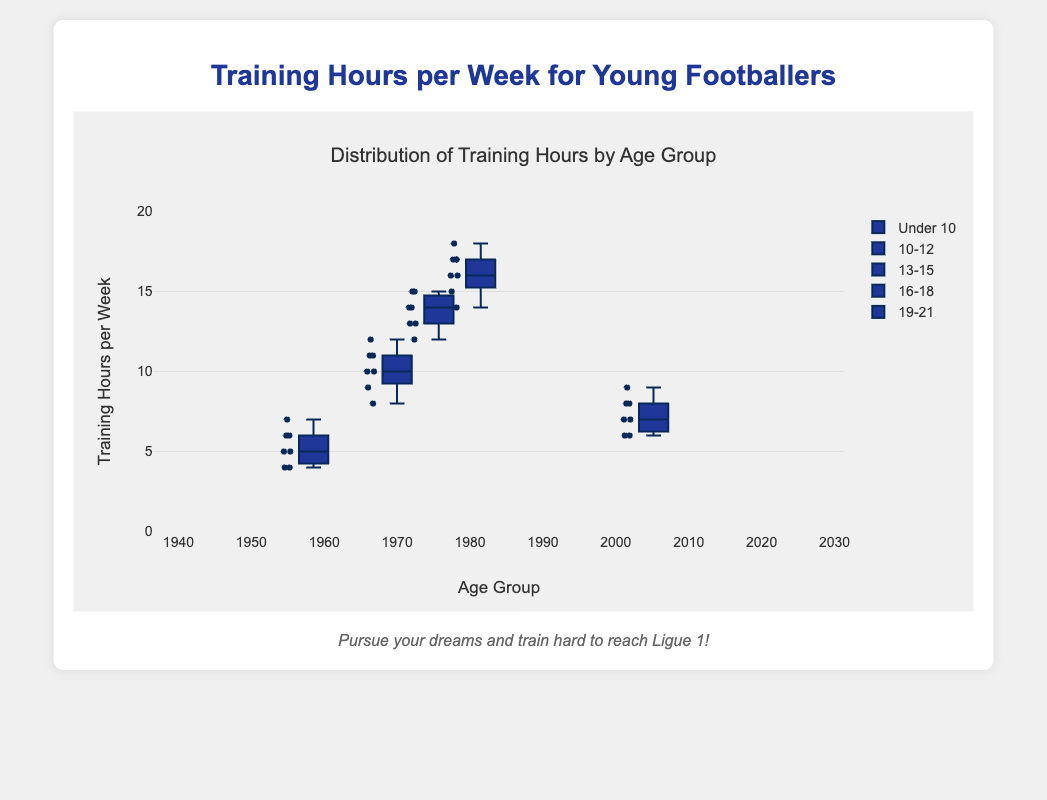What is the title of the box plot? The title of the box plot is usually displayed at the top of the figure. In this case, it reads "Distribution of Training Hours by Age Group".
Answer: Distribution of Training Hours by Age Group What is the median training hours per week for the 10-12 age group? To find the median training hours for the 10-12 age group, look at the middle line within the box for that age group. This line represents the median.
Answer: 7 hours Which age group has the highest median training hours per week? By examining the middle line (median) within each box, we identify the group with the highest median training hours. The 19-21 age group has the highest median value.
Answer: 19-21 age group How do the training hours for the Under 10 age group compare to the 13-15 age group in terms of range? To compare the range, look at the spread of the whiskers (vertical lines) for each group. The range for the Under 10 age group is from 4 hours to 7 hours, while the range for the 13-15 age group is from 8 hours to 12 hours. Thus, the 13-15 age group has a wider range of training hours.
Answer: 13-15 age group has a wider range What is the interquartile range (IQR) of training hours for the 16-18 age group? The interquartile range is the difference between the third quartile (top of the box) and the first quartile (bottom of the box). For the 16-18 age group, look at these values on the box plot, which are 15 and 13, respectively. So, IQR = 15 - 13.
Answer: 2 hours Which age group has the heaviest outliers in terms of training hours? Outliers are usually represented by points outside the whiskers. The 19-21 age group shows no distinct outliers. Therefore, none of the age groups has heavy outliers.
Answer: None What is the overall trend in training hours as age increases? By observing the medians across different age groups, it is apparent that the median training hours increase with age.
Answer: Training hours increase with age How many data points are there for the 13-15 age group? To find the number of data points, count the individual points on the plot for a specific age group. The 13-15 age group has 7 data points.
Answer: 7 data points Which age group has the most consistent (least variable) training hours per week? Consistency can be assessed by examining the size of the box (IQR) and the length of the whiskers. The Under 10 age group shows less variability compared to other groups.
Answer: Under 10 age group 